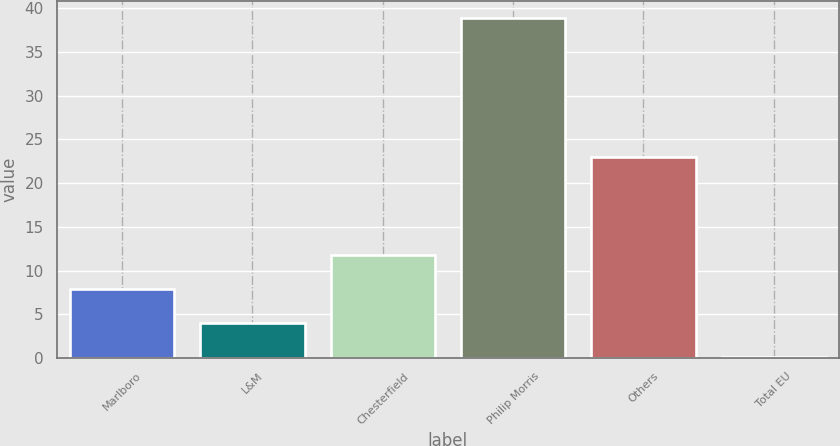Convert chart. <chart><loc_0><loc_0><loc_500><loc_500><bar_chart><fcel>Marlboro<fcel>L&M<fcel>Chesterfield<fcel>Philip Morris<fcel>Others<fcel>Total EU<nl><fcel>7.86<fcel>3.98<fcel>11.74<fcel>38.9<fcel>23<fcel>0.1<nl></chart> 